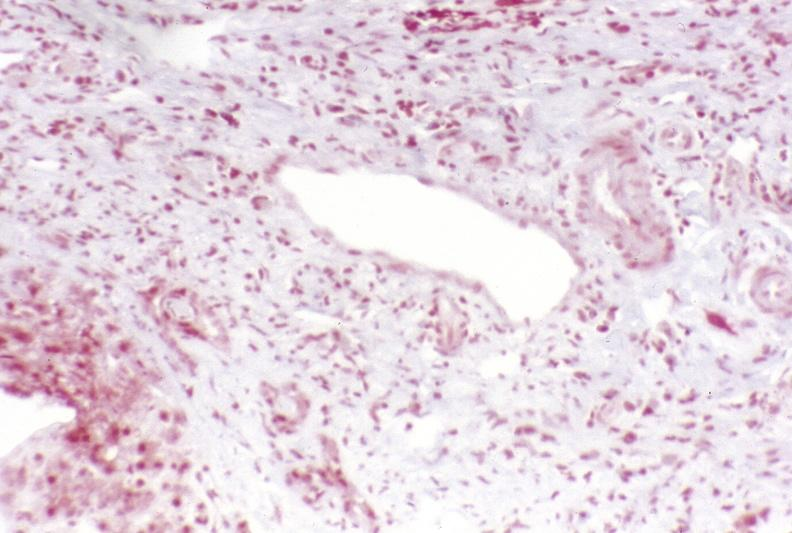what is present?
Answer the question using a single word or phrase. Hepatobiliary 